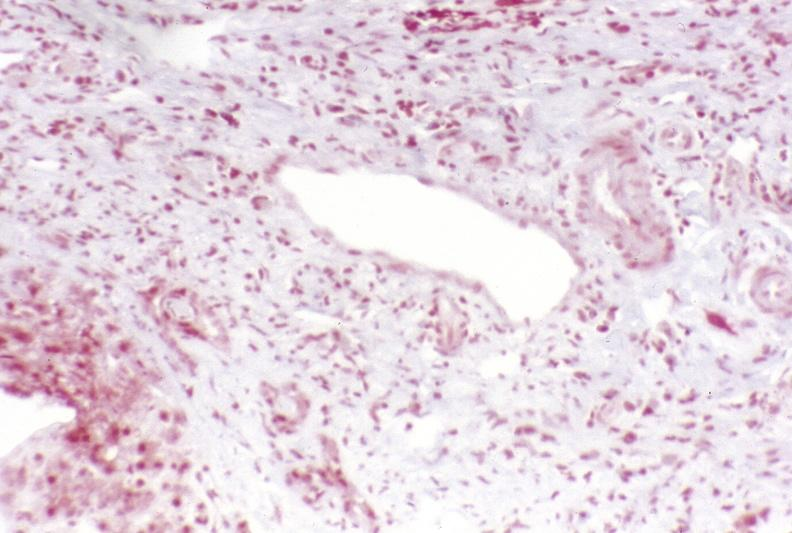what is present?
Answer the question using a single word or phrase. Hepatobiliary 